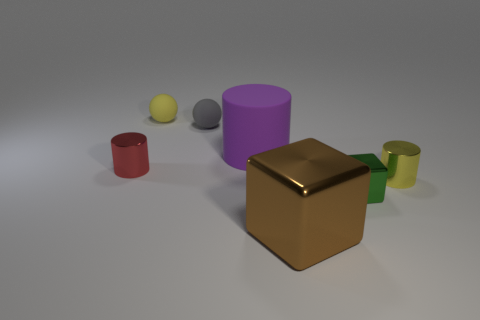Add 2 shiny blocks. How many objects exist? 9 Subtract all cylinders. How many objects are left? 4 Subtract all tiny green metal objects. Subtract all brown matte spheres. How many objects are left? 6 Add 4 small shiny objects. How many small shiny objects are left? 7 Add 6 purple matte cylinders. How many purple matte cylinders exist? 7 Subtract 0 cyan cylinders. How many objects are left? 7 